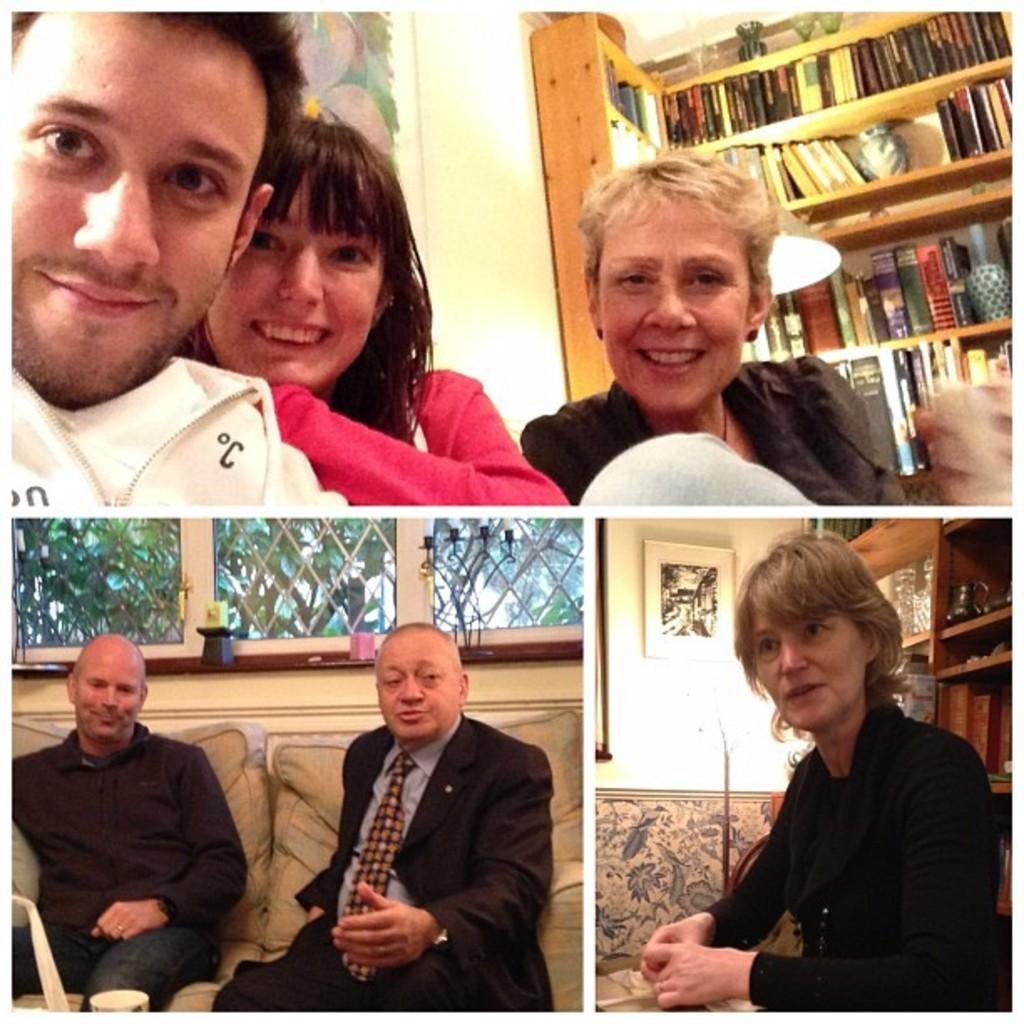Describe this image in one or two sentences. This is an edited picture, on the top, there is a man and two women having smile on their faces and posing to a camera. In the background, there is a bookshelf and a wall. On the bottom left side of the image consisting of two men siting on a couch and there is a glass window and a candle holder in the background. On the bottom right side of the image consisting of a woman in black dress. In the background, there is a rack, lamp, wall and a photo frame on it. 